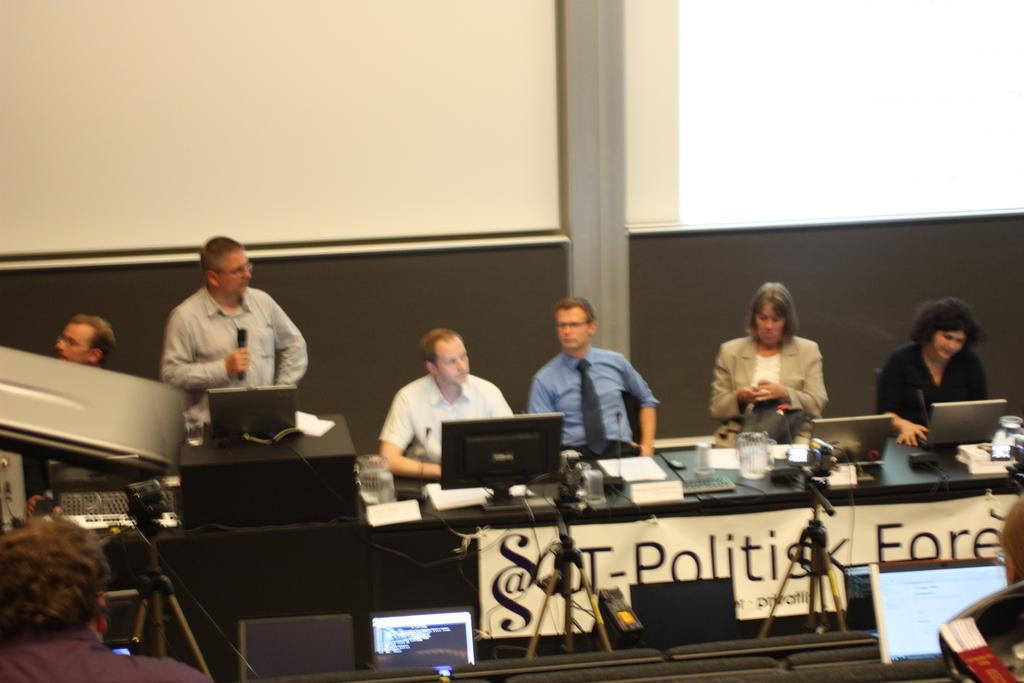Could you give a brief overview of what you see in this image? In this image we can see the people sitting on the chairs in front of the table and on the table we can see the monitor, laptops, glasses, papers and also some other objects. We can also see the cameras with stands. In the background, we can see the wall. 